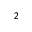Convert formula to latex. <formula><loc_0><loc_0><loc_500><loc_500>_ { 2 }</formula> 